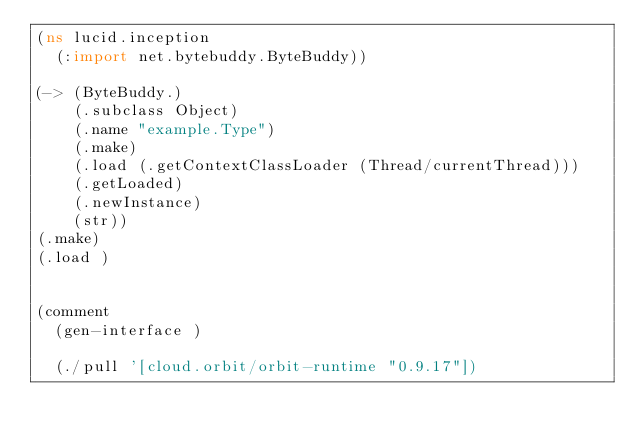<code> <loc_0><loc_0><loc_500><loc_500><_Clojure_>(ns lucid.inception
  (:import net.bytebuddy.ByteBuddy))

(-> (ByteBuddy.)
    (.subclass Object)
    (.name "example.Type")
    (.make)
    (.load (.getContextClassLoader (Thread/currentThread)))
    (.getLoaded)
    (.newInstance)
    (str))
(.make)
(.load )


(comment
  (gen-interface )

  (./pull '[cloud.orbit/orbit-runtime "0.9.17"])</code> 